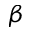Convert formula to latex. <formula><loc_0><loc_0><loc_500><loc_500>\beta</formula> 